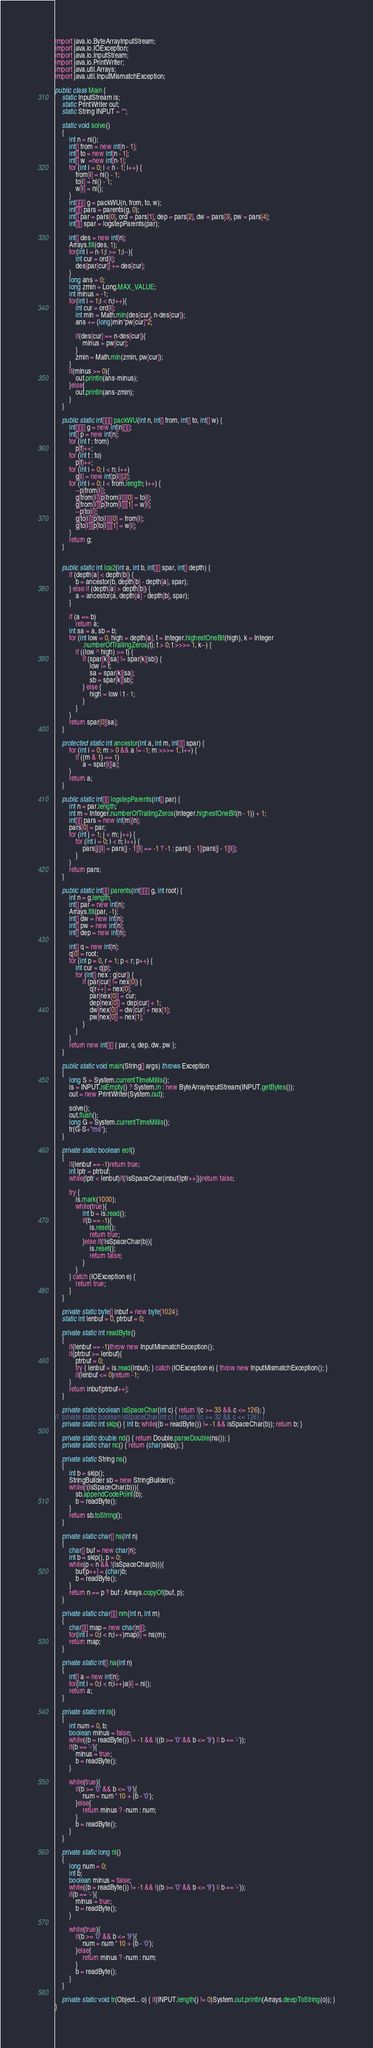Convert code to text. <code><loc_0><loc_0><loc_500><loc_500><_Java_>import java.io.ByteArrayInputStream;
import java.io.IOException;
import java.io.InputStream;
import java.io.PrintWriter;
import java.util.Arrays;
import java.util.InputMismatchException;

public class Main {
	static InputStream is;
	static PrintWriter out;
	static String INPUT = "";
	
	static void solve()
	{
		int n = ni();
		int[] from = new int[n - 1];
		int[] to = new int[n - 1];
		int[] w  =new int[n-1];
		for (int i = 0; i < n - 1; i++) {
			from[i] = ni() - 1;
			to[i] = ni() - 1;
			w[i] = ni();
		}
		int[][][] g = packWU(n, from, to, w);
		int[][] pars = parents(g, 0);
		int[] par = pars[0], ord = pars[1], dep = pars[2], dw = pars[3], pw = pars[4];
		int[][] spar = logstepParents(par);
		
		int[] des = new int[n];
		Arrays.fill(des, 1);
		for(int i = n-1;i >= 1;i--){
			int cur = ord[i];
			des[par[cur]] += des[cur];
		}
		long ans = 0;
		long zmin = Long.MAX_VALUE;
		int minus = -1;
		for(int i = 1;i < n;i++){
			int cur = ord[i];
			int min = Math.min(des[cur], n-des[cur]);
			ans += (long)min*pw[cur]*2;
			
			if(des[cur] == n-des[cur]){
				minus = pw[cur];
			}
			zmin = Math.min(zmin, pw[cur]);
		}
		if(minus >= 0){
			out.println(ans-minus);
		}else{
			out.println(ans-zmin);
		}
	}
	
	public static int[][][] packWU(int n, int[] from, int[] to, int[] w) {
		int[][][] g = new int[n][][];
		int[] p = new int[n];
		for (int f : from)
			p[f]++;
		for (int t : to)
			p[t]++;
		for (int i = 0; i < n; i++)
			g[i] = new int[p[i]][2];
		for (int i = 0; i < from.length; i++) {
			--p[from[i]];
			g[from[i]][p[from[i]]][0] = to[i];
			g[from[i]][p[from[i]]][1] = w[i];
			--p[to[i]];
			g[to[i]][p[to[i]]][0] = from[i];
			g[to[i]][p[to[i]]][1] = w[i];
		}
		return g;
	}

	
	public static int lca2(int a, int b, int[][] spar, int[] depth) {
		if (depth[a] < depth[b]) {
			b = ancestor(b, depth[b] - depth[a], spar);
		} else if (depth[a] > depth[b]) {
			a = ancestor(a, depth[a] - depth[b], spar);
		}

		if (a == b)
			return a;
		int sa = a, sb = b;
		for (int low = 0, high = depth[a], t = Integer.highestOneBit(high), k = Integer
				.numberOfTrailingZeros(t); t > 0; t >>>= 1, k--) {
			if ((low ^ high) >= t) {
				if (spar[k][sa] != spar[k][sb]) {
					low |= t;
					sa = spar[k][sa];
					sb = spar[k][sb];
				} else {
					high = low | t - 1;
				}
			}
		}
		return spar[0][sa];
	}

	protected static int ancestor(int a, int m, int[][] spar) {
		for (int i = 0; m > 0 && a != -1; m >>>= 1, i++) {
			if ((m & 1) == 1)
				a = spar[i][a];
		}
		return a;
	}

	public static int[][] logstepParents(int[] par) {
		int n = par.length;
		int m = Integer.numberOfTrailingZeros(Integer.highestOneBit(n - 1)) + 1;
		int[][] pars = new int[m][n];
		pars[0] = par;
		for (int j = 1; j < m; j++) {
			for (int i = 0; i < n; i++) {
				pars[j][i] = pars[j - 1][i] == -1 ? -1 : pars[j - 1][pars[j - 1][i]];
			}
		}
		return pars;
	}

	public static int[][] parents(int[][][] g, int root) {
		int n = g.length;
		int[] par = new int[n];
		Arrays.fill(par, -1);
		int[] dw = new int[n];
		int[] pw = new int[n];
		int[] dep = new int[n];

		int[] q = new int[n];
		q[0] = root;
		for (int p = 0, r = 1; p < r; p++) {
			int cur = q[p];
			for (int[] nex : g[cur]) {
				if (par[cur] != nex[0]) {
					q[r++] = nex[0];
					par[nex[0]] = cur;
					dep[nex[0]] = dep[cur] + 1;
					dw[nex[0]] = dw[cur] + nex[1];
					pw[nex[0]] = nex[1];
				}
			}
		}
		return new int[][] { par, q, dep, dw, pw };
	}
	
	public static void main(String[] args) throws Exception
	{
		long S = System.currentTimeMillis();
		is = INPUT.isEmpty() ? System.in : new ByteArrayInputStream(INPUT.getBytes());
		out = new PrintWriter(System.out);
		
		solve();
		out.flush();
		long G = System.currentTimeMillis();
		tr(G-S+"ms");
	}
	
	private static boolean eof()
	{
		if(lenbuf == -1)return true;
		int lptr = ptrbuf;
		while(lptr < lenbuf)if(!isSpaceChar(inbuf[lptr++]))return false;
		
		try {
			is.mark(1000);
			while(true){
				int b = is.read();
				if(b == -1){
					is.reset();
					return true;
				}else if(!isSpaceChar(b)){
					is.reset();
					return false;
				}
			}
		} catch (IOException e) {
			return true;
		}
	}
	
	private static byte[] inbuf = new byte[1024];
	static int lenbuf = 0, ptrbuf = 0;
	
	private static int readByte()
	{
		if(lenbuf == -1)throw new InputMismatchException();
		if(ptrbuf >= lenbuf){
			ptrbuf = 0;
			try { lenbuf = is.read(inbuf); } catch (IOException e) { throw new InputMismatchException(); }
			if(lenbuf <= 0)return -1;
		}
		return inbuf[ptrbuf++];
	}
	
	private static boolean isSpaceChar(int c) { return !(c >= 33 && c <= 126); }
//	private static boolean isSpaceChar(int c) { return !(c >= 32 && c <= 126); }
	private static int skip() { int b; while((b = readByte()) != -1 && isSpaceChar(b)); return b; }
	
	private static double nd() { return Double.parseDouble(ns()); }
	private static char nc() { return (char)skip(); }
	
	private static String ns()
	{
		int b = skip();
		StringBuilder sb = new StringBuilder();
		while(!(isSpaceChar(b))){
			sb.appendCodePoint(b);
			b = readByte();
		}
		return sb.toString();
	}
	
	private static char[] ns(int n)
	{
		char[] buf = new char[n];
		int b = skip(), p = 0;
		while(p < n && !(isSpaceChar(b))){
			buf[p++] = (char)b;
			b = readByte();
		}
		return n == p ? buf : Arrays.copyOf(buf, p);
	}
	
	private static char[][] nm(int n, int m)
	{
		char[][] map = new char[n][];
		for(int i = 0;i < n;i++)map[i] = ns(m);
		return map;
	}
	
	private static int[] na(int n)
	{
		int[] a = new int[n];
		for(int i = 0;i < n;i++)a[i] = ni();
		return a;
	}
	
	private static int ni()
	{
		int num = 0, b;
		boolean minus = false;
		while((b = readByte()) != -1 && !((b >= '0' && b <= '9') || b == '-'));
		if(b == '-'){
			minus = true;
			b = readByte();
		}
		
		while(true){
			if(b >= '0' && b <= '9'){
				num = num * 10 + (b - '0');
			}else{
				return minus ? -num : num;
			}
			b = readByte();
		}
	}
	
	private static long nl()
	{
		long num = 0;
		int b;
		boolean minus = false;
		while((b = readByte()) != -1 && !((b >= '0' && b <= '9') || b == '-'));
		if(b == '-'){
			minus = true;
			b = readByte();
		}
		
		while(true){
			if(b >= '0' && b <= '9'){
				num = num * 10 + (b - '0');
			}else{
				return minus ? -num : num;
			}
			b = readByte();
		}
	}
	
	private static void tr(Object... o) { if(INPUT.length() != 0)System.out.println(Arrays.deepToString(o)); }
}
</code> 